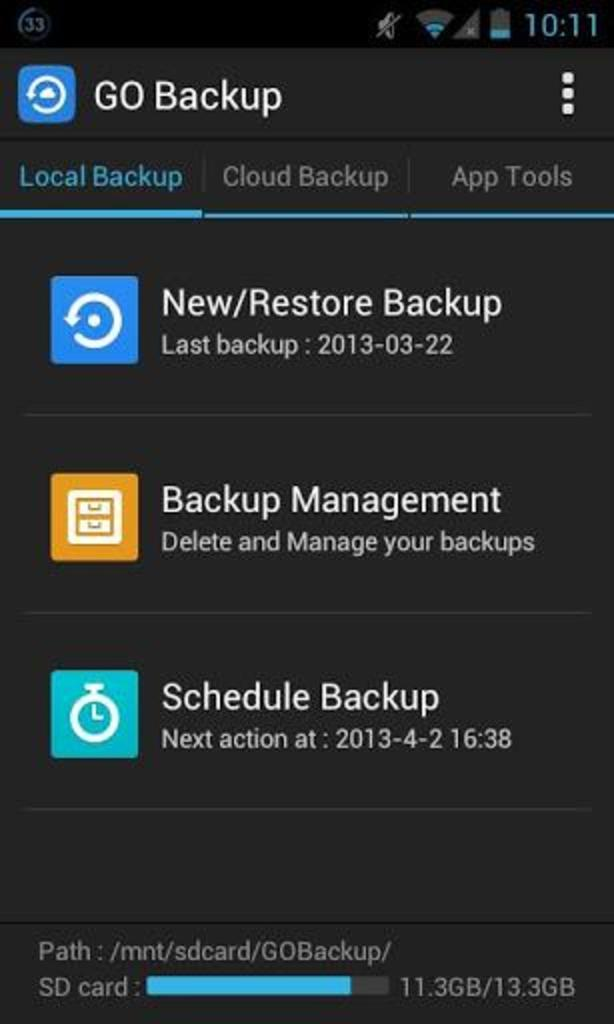<image>
Offer a succinct explanation of the picture presented. A device on the go backup page showing it as 10:11. 